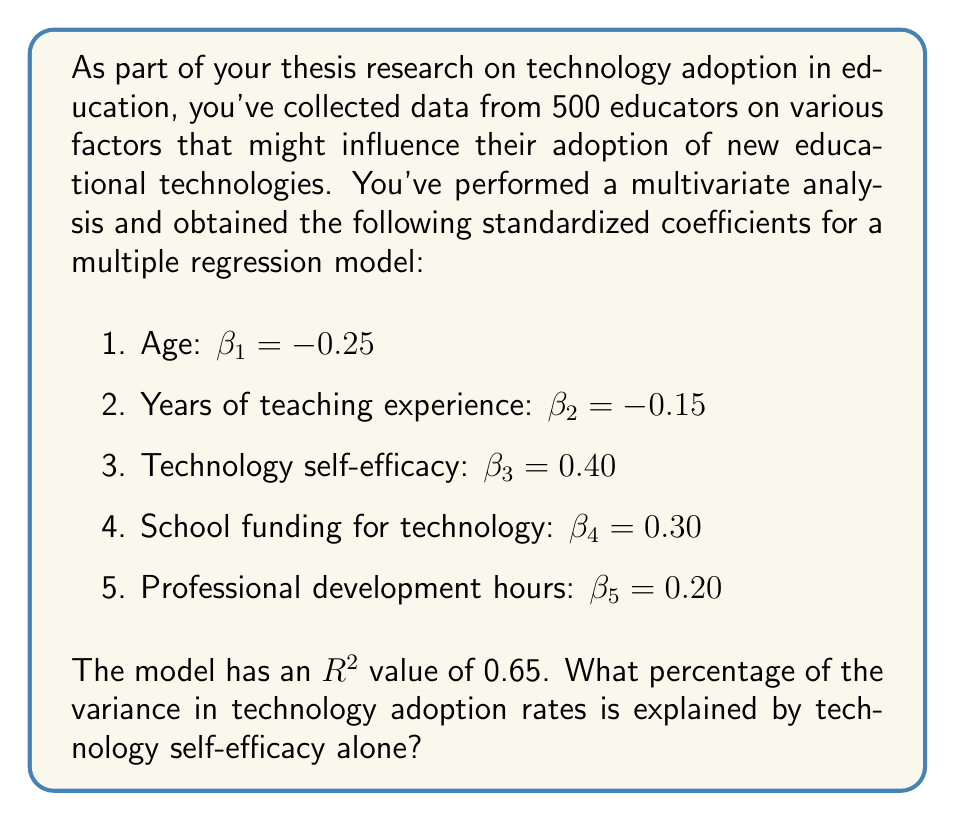Can you solve this math problem? To solve this problem, we need to follow these steps:

1. Understand the meaning of standardized coefficients ($\beta$):
   Standardized coefficients represent the change in the dependent variable (in standard deviation units) for a one standard deviation change in the independent variable.

2. Calculate the total explained variance:
   The $R^2$ value of 0.65 indicates that 65% of the variance in technology adoption rates is explained by all variables in the model.

3. Calculate the squared standardized coefficient for technology self-efficacy:
   $\beta_3^2 = 0.40^2 = 0.16$

4. Calculate the sum of squared standardized coefficients:
   $\sum \beta_i^2 = (-0.25)^2 + (-0.15)^2 + 0.40^2 + 0.30^2 + 0.20^2$
   $= 0.0625 + 0.0225 + 0.16 + 0.09 + 0.04$
   $= 0.375$

5. Calculate the proportion of explained variance attributed to technology self-efficacy:
   $\frac{\beta_3^2}{\sum \beta_i^2} = \frac{0.16}{0.375} = 0.4267$

6. Calculate the percentage of total variance explained by technology self-efficacy:
   $0.4267 \times R^2 = 0.4267 \times 0.65 = 0.2773$

7. Convert to a percentage:
   $0.2773 \times 100\% = 27.73\%$

Therefore, technology self-efficacy alone explains 27.73% of the variance in technology adoption rates.
Answer: 27.73% 